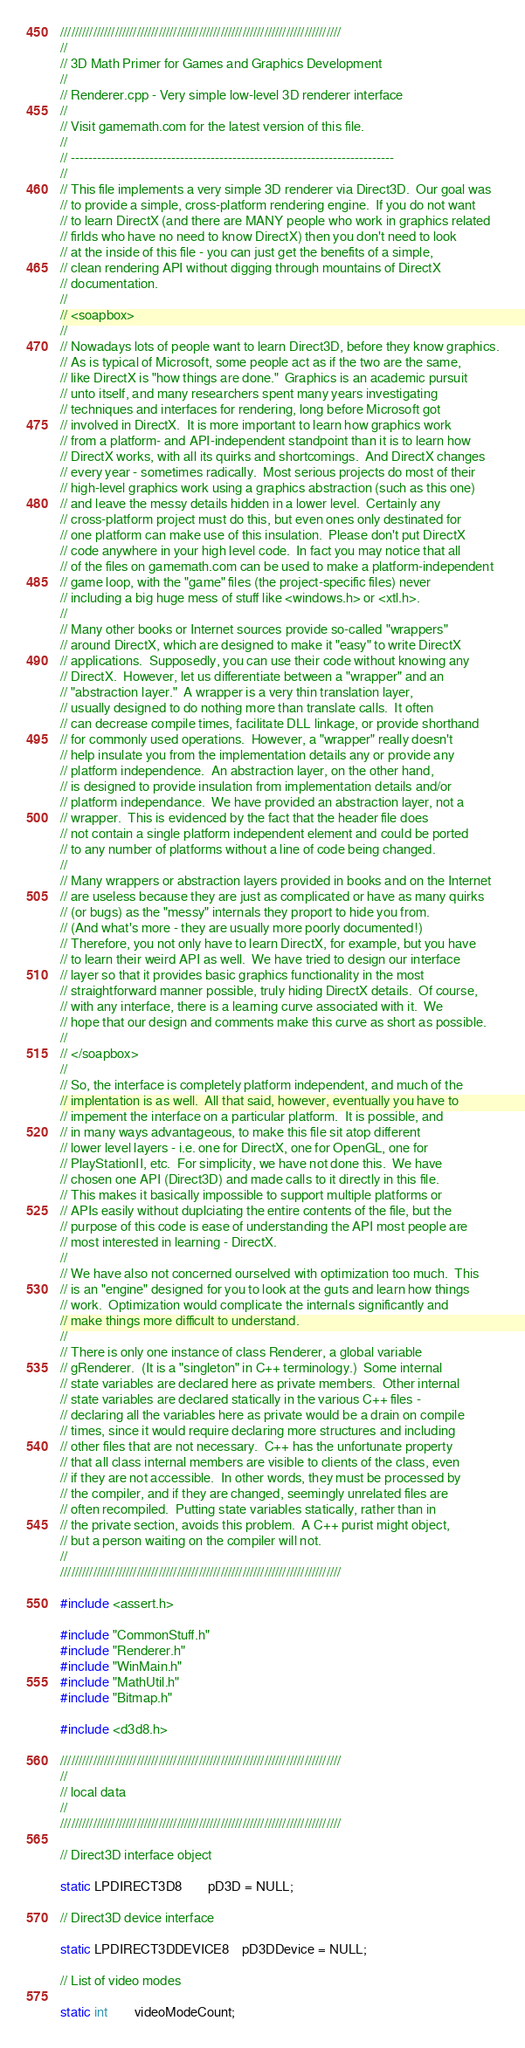<code> <loc_0><loc_0><loc_500><loc_500><_C++_>/////////////////////////////////////////////////////////////////////////////
//
// 3D Math Primer for Games and Graphics Development
//
// Renderer.cpp - Very simple low-level 3D renderer interface
//
// Visit gamemath.com for the latest version of this file.
//
// --------------------------------------------------------------------------
//
// This file implements a very simple 3D renderer via Direct3D.  Our goal was
// to provide a simple, cross-platform rendering engine.  If you do not want
// to learn DirectX (and there are MANY people who work in graphics related
// firlds who have no need to know DirectX) then you don't need to look
// at the inside of this file - you can just get the benefits of a simple,
// clean rendering API without digging through mountains of DirectX
// documentation.
//
// <soapbox>
//
// Nowadays lots of people want to learn Direct3D, before they know graphics.
// As is typical of Microsoft, some people act as if the two are the same,
// like DirectX is "how things are done."  Graphics is an academic pursuit
// unto itself, and many researchers spent many years investigating
// techniques and interfaces for rendering, long before Microsoft got
// involved in DirectX.  It is more important to learn how graphics work
// from a platform- and API-independent standpoint than it is to learn how
// DirectX works, with all its quirks and shortcomings.  And DirectX changes
// every year - sometimes radically.  Most serious projects do most of their
// high-level graphics work using a graphics abstraction (such as this one)
// and leave the messy details hidden in a lower level.  Certainly any
// cross-platform project must do this, but even ones only destinated for
// one platform can make use of this insulation.  Please don't put DirectX
// code anywhere in your high level code.  In fact you may notice that all
// of the files on gamemath.com can be used to make a platform-independent
// game loop, with the "game" files (the project-specific files) never
// including a big huge mess of stuff like <windows.h> or <xtl.h>.
//
// Many other books or Internet sources provide so-called "wrappers"
// around DirectX, which are designed to make it "easy" to write DirectX
// applications.  Supposedly, you can use their code without knowing any
// DirectX.  However, let us differentiate between a "wrapper" and an
// "abstraction layer."  A wrapper is a very thin translation layer,
// usually designed to do nothing more than translate calls.  It often
// can decrease compile times, facilitate DLL linkage, or provide shorthand
// for commonly used operations.  However, a "wrapper" really doesn't
// help insulate you from the implementation details any or provide any
// platform independence.  An abstraction layer, on the other hand,
// is designed to provide insulation from implementation details and/or
// platform independance.  We have provided an abstraction layer, not a
// wrapper.  This is evidenced by the fact that the header file does
// not contain a single platform independent element and could be ported
// to any number of platforms without a line of code being changed.
//
// Many wrappers or abstraction layers provided in books and on the Internet
// are useless because they are just as complicated or have as many quirks
// (or bugs) as the "messy" internals they proport to hide you from.
// (And what's more - they are usually more poorly documented!)
// Therefore, you not only have to learn DirectX, for example, but you have
// to learn their weird API as well.  We have tried to design our interface
// layer so that it provides basic graphics functionality in the most
// straightforward manner possible, truly hiding DirectX details.  Of course,
// with any interface, there is a learning curve associated with it.  We
// hope that our design and comments make this curve as short as possible.
//
// </soapbox>
//
// So, the interface is completely platform independent, and much of the
// implentation is as well.  All that said, however, eventually you have to
// impement the interface on a particular platform.  It is possible, and
// in many ways advantageous, to make this file sit atop different
// lower level layers - i.e. one for DirectX, one for OpenGL, one for
// PlayStationII, etc.  For simplicity, we have not done this.  We have
// chosen one API (Direct3D) and made calls to it directly in this file.
// This makes it basically impossible to support multiple platforms or
// APIs easily without duplciating the entire contents of the file, but the
// purpose of this code is ease of understanding the API most people are
// most interested in learning - DirectX.
//
// We have also not concerned ourselved with optimization too much.  This
// is an "engine" designed for you to look at the guts and learn how things
// work.  Optimization would complicate the internals significantly and
// make things more difficult to understand.
//
// There is only one instance of class Renderer, a global variable
// gRenderer.  (It is a "singleton" in C++ terminology.)  Some internal
// state variables are declared here as private members.  Other internal
// state variables are declared statically in the various C++ files -
// declaring all the variables here as private would be a drain on compile
// times, since it would require declaring more structures and including
// other files that are not necessary.  C++ has the unfortunate property
// that all class internal members are visible to clients of the class, even
// if they are not accessible.  In other words, they must be processed by
// the compiler, and if they are changed, seemingly unrelated files are
// often recompiled.  Putting state variables statically, rather than in
// the private section, avoids this problem.  A C++ purist might object,
// but a person waiting on the compiler will not.
//
/////////////////////////////////////////////////////////////////////////////

#include <assert.h>

#include "CommonStuff.h"
#include "Renderer.h"
#include "WinMain.h"
#include "MathUtil.h"
#include "Bitmap.h"

#include <d3d8.h>

/////////////////////////////////////////////////////////////////////////////
//
// local data
//
/////////////////////////////////////////////////////////////////////////////

// Direct3D interface object

static LPDIRECT3D8 		pD3D = NULL;

// Direct3D device interface

static LPDIRECT3DDEVICE8 	pD3DDevice = NULL;

// List of video modes

static int		videoModeCount;</code> 